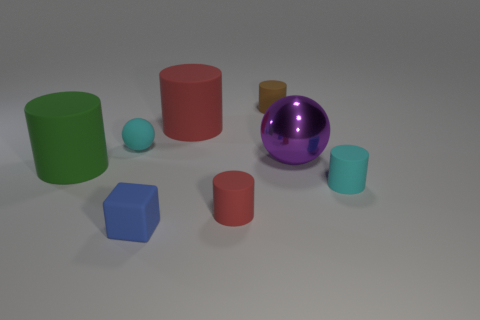What shape is the large matte thing that is to the right of the big matte cylinder in front of the cyan matte object on the left side of the brown cylinder?
Keep it short and to the point. Cylinder. The rubber thing that is the same color as the tiny matte sphere is what shape?
Your answer should be very brief. Cylinder. There is a tiny cylinder that is left of the large purple metal sphere and in front of the purple metal sphere; what is its material?
Keep it short and to the point. Rubber. Are there fewer blue rubber blocks than red rubber cylinders?
Ensure brevity in your answer.  Yes. Does the big red thing have the same shape as the cyan matte object right of the tiny brown cylinder?
Offer a very short reply. Yes. There is a brown rubber object that is behind the green thing; does it have the same size as the blue object?
Provide a short and direct response. Yes. What shape is the red rubber object that is the same size as the purple metallic sphere?
Ensure brevity in your answer.  Cylinder. Is the tiny red rubber object the same shape as the big red object?
Offer a very short reply. Yes. What number of tiny red things have the same shape as the big red thing?
Keep it short and to the point. 1. There is a cyan cylinder; what number of small cyan rubber objects are behind it?
Keep it short and to the point. 1. 